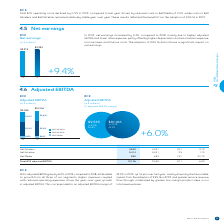According to Bce's financial document, How much did BCE's adjusted EBITDA grow by in 2019? According to the financial document, 6.0%. The relevant text states: "Total BCE adjusted EBITDA 10,106 9,535 571 6.0%..." Also, What was the $ CHANGE in Bell Media? According to the financial document, 157. The relevant text states: "Bell Media 850 693 157 22.7%..." Also, What is the adjusted EBITDA margin in 2019? According to the financial document, 42.2%. The relevant text states: "$10,106 in 2019 42.2%..." Also, can you calculate: What is the total Adjusted EBITDA for Bell Wireless in 2018 and 2019? Based on the calculation: 3,842+3,521, the result is 7363. This is based on the information: "Bell Wireless 3,842 3,521 321 9.1% Bell Wireless 3,842 3,521 321 9.1%..." The key data points involved are: 3,521, 3,842. Also, can you calculate: What is the percentage of Bell Wireline of the total BCE adjusted EBITDA in 2019? Based on the calculation: 5,414/10,106, the result is 53.57 (percentage). This is based on the information: "Total BCE adjusted EBITDA 10,106 9,535 571 6.0% Bell Wireline 5,414 5,321 93 1.7%..." The key data points involved are: 10,106, 5,414. Also, can you calculate: What is the difference in the Adjusted EBITDA for Bell Wireless and Bell Wireline in 2018? Based on the calculation: 5,321-3,521, the result is 1800. This is based on the information: "Bell Wireless 3,842 3,521 321 9.1% Bell Wireline 5,414 5,321 93 1.7%..." The key data points involved are: 3,521, 5,321. 